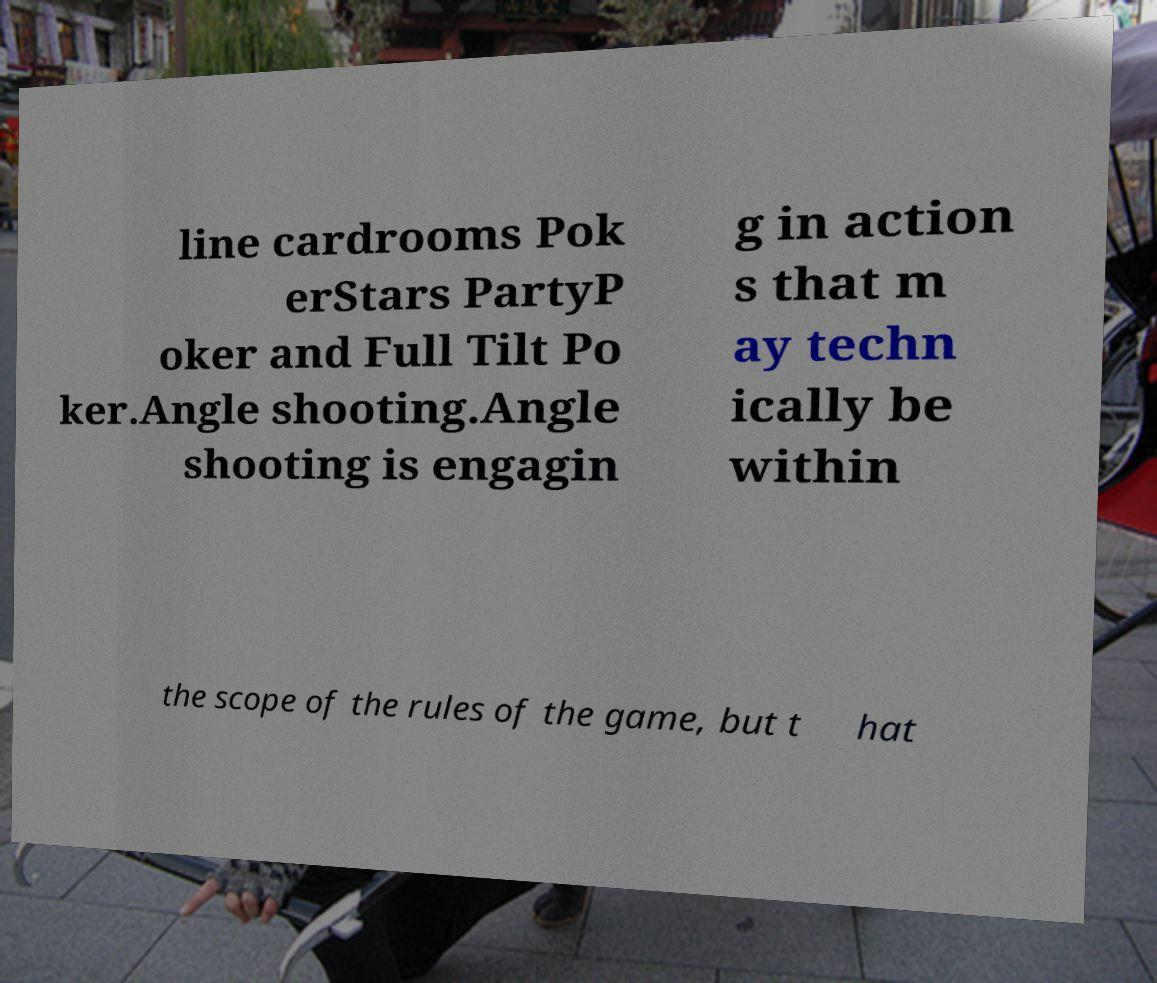I need the written content from this picture converted into text. Can you do that? line cardrooms Pok erStars PartyP oker and Full Tilt Po ker.Angle shooting.Angle shooting is engagin g in action s that m ay techn ically be within the scope of the rules of the game, but t hat 